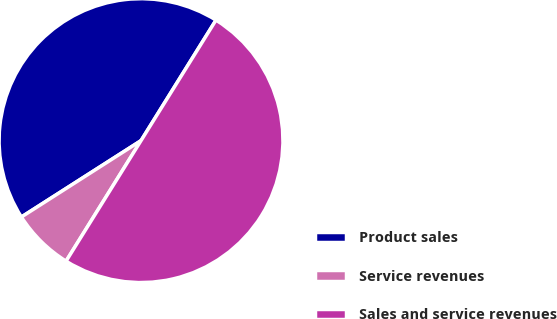Convert chart. <chart><loc_0><loc_0><loc_500><loc_500><pie_chart><fcel>Product sales<fcel>Service revenues<fcel>Sales and service revenues<nl><fcel>42.9%<fcel>7.1%<fcel>50.0%<nl></chart> 